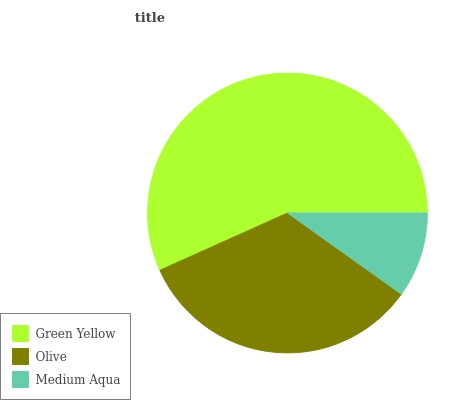Is Medium Aqua the minimum?
Answer yes or no. Yes. Is Green Yellow the maximum?
Answer yes or no. Yes. Is Olive the minimum?
Answer yes or no. No. Is Olive the maximum?
Answer yes or no. No. Is Green Yellow greater than Olive?
Answer yes or no. Yes. Is Olive less than Green Yellow?
Answer yes or no. Yes. Is Olive greater than Green Yellow?
Answer yes or no. No. Is Green Yellow less than Olive?
Answer yes or no. No. Is Olive the high median?
Answer yes or no. Yes. Is Olive the low median?
Answer yes or no. Yes. Is Medium Aqua the high median?
Answer yes or no. No. Is Medium Aqua the low median?
Answer yes or no. No. 